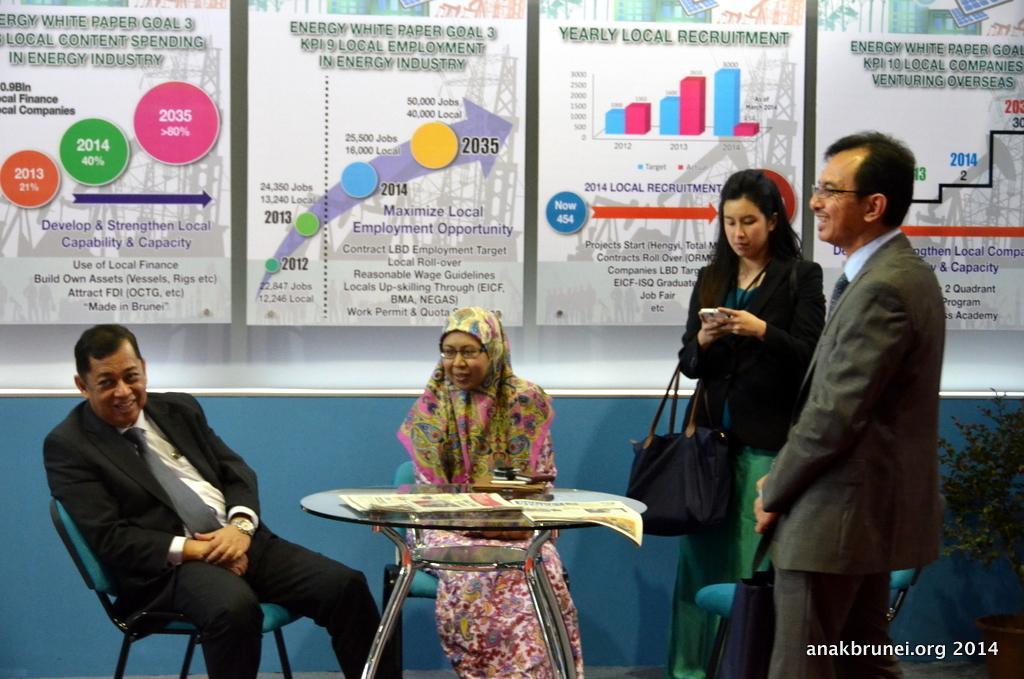Please provide a concise description of this image. In this picture these two persons sitting on the chair. These persons standing. This person holding a bag. We can see table. On the table we can see papers. On the background we can see wall and boards. 